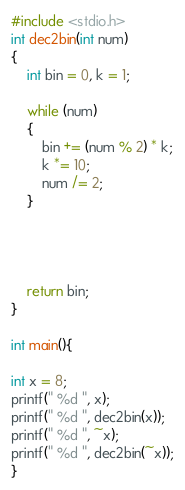<code> <loc_0><loc_0><loc_500><loc_500><_C_>#include <stdio.h>
int dec2bin(int num)
{
    int bin = 0, k = 1;

    while (num)
    {
        bin += (num % 2) * k;
        k *= 10;
        num /= 2;
    }




    return bin;
}

int main(){

int x = 8;
printf(" %d ", x);
printf(" %d ", dec2bin(x));
printf(" %d ", ~x);
printf(" %d ", dec2bin(~x));
}
</code> 